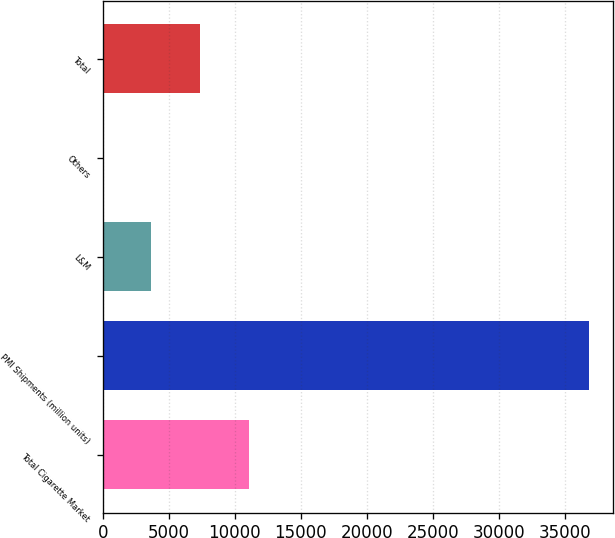Convert chart. <chart><loc_0><loc_0><loc_500><loc_500><bar_chart><fcel>Total Cigarette Market<fcel>PMI Shipments (million units)<fcel>L&M<fcel>Others<fcel>Total<nl><fcel>11056.2<fcel>36849<fcel>3686.79<fcel>2.1<fcel>7371.48<nl></chart> 